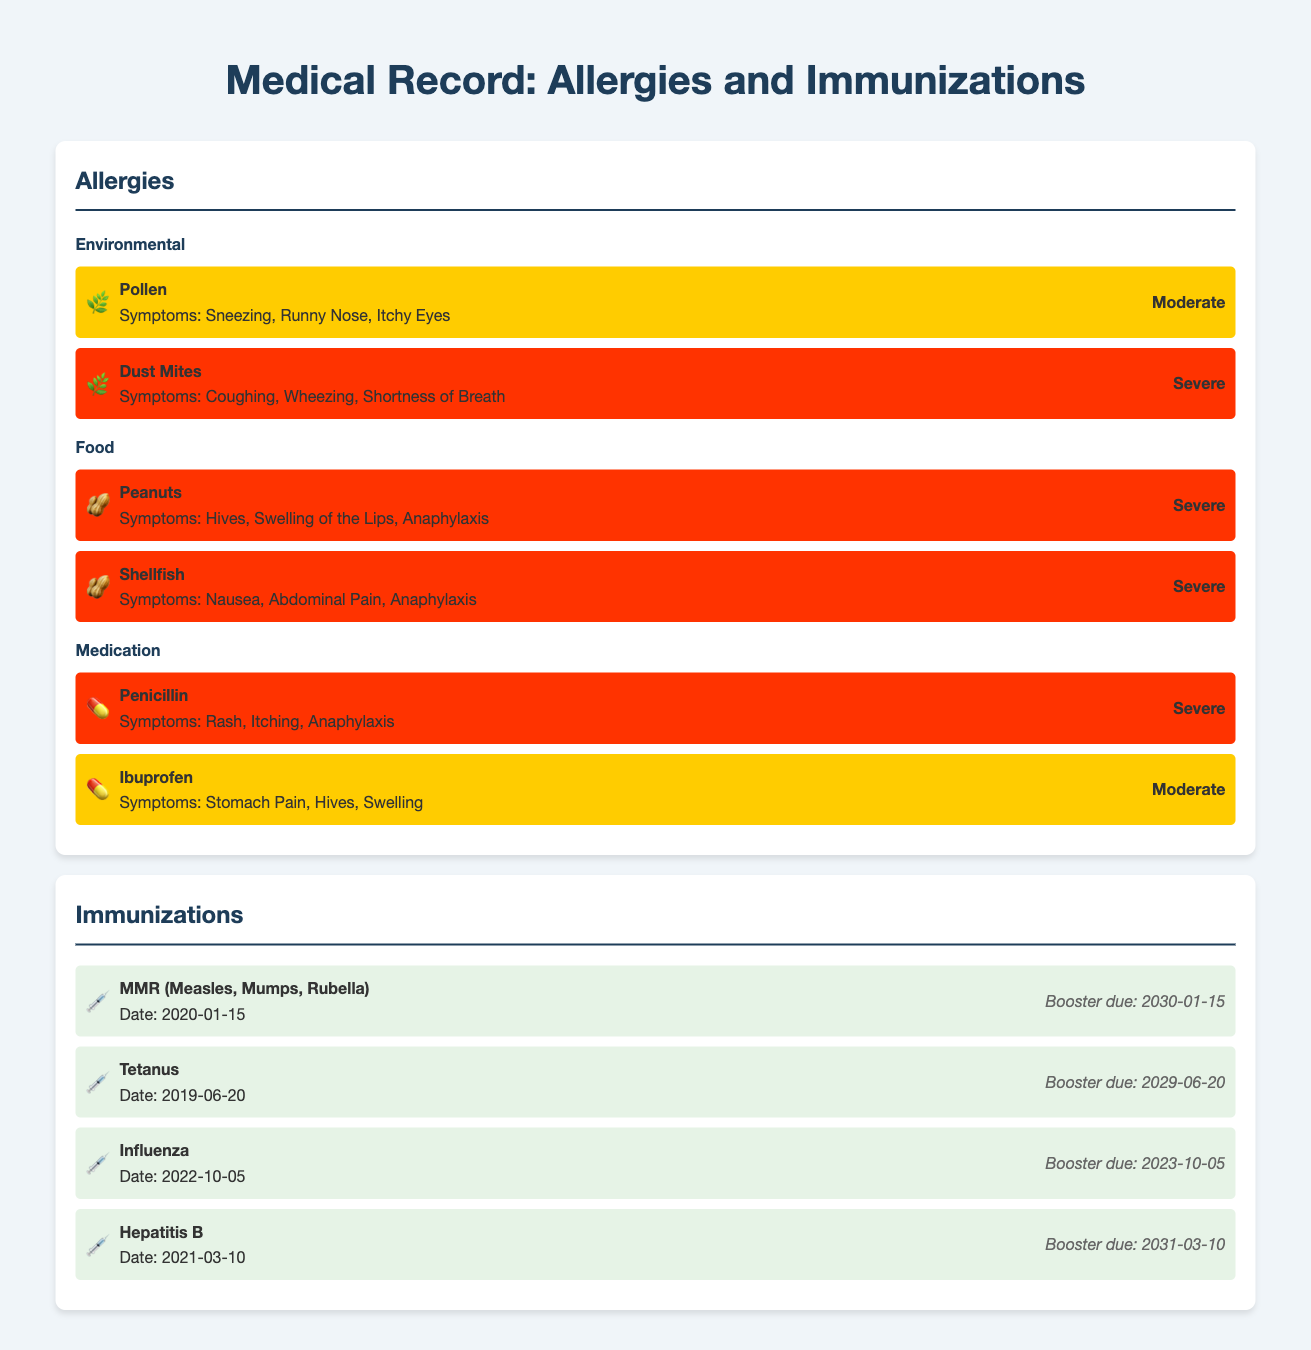What is the severity of the pollen allergy? The severity of the pollen allergy is indicated as "Moderate" in the document.
Answer: Moderate When was the last time the influenza vaccine was received? The date for the influenza vaccine is specified as October 5, 2022, in the immunizations section.
Answer: 2022-10-05 What symptoms are associated with peanut allergies? The document specifies that symptoms of peanut allergies include "Hives, Swelling of the Lips, Anaphylaxis."
Answer: Hives, Swelling of the Lips, Anaphylaxis Which immunization has the earliest booster due date? The booster due for Tetanus is set for June 20, 2029, which is the earliest date among the immunizations listed.
Answer: 2029-06-20 What type of allergy is associated with shellfish? The document categorizes shellfish allergies under the "Food" allergy type.
Answer: Food How many medication allergies are listed? There are two medication allergies specified in the document.
Answer: 2 